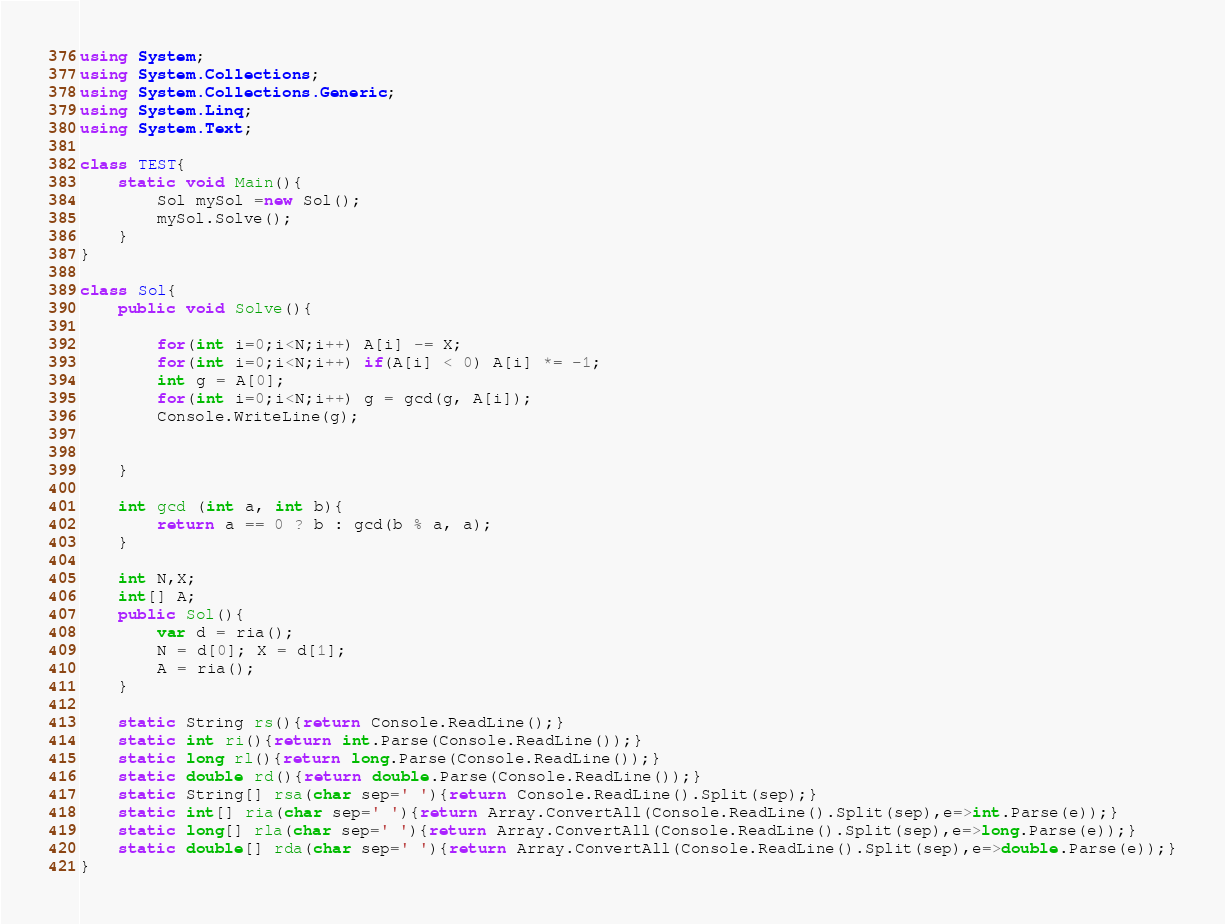Convert code to text. <code><loc_0><loc_0><loc_500><loc_500><_C#_>using System;
using System.Collections;
using System.Collections.Generic;
using System.Linq;
using System.Text;

class TEST{
	static void Main(){
		Sol mySol =new Sol();
		mySol.Solve();
	}
}

class Sol{
	public void Solve(){
		
		for(int i=0;i<N;i++) A[i] -= X;
		for(int i=0;i<N;i++) if(A[i] < 0) A[i] *= -1;
		int g = A[0];
		for(int i=0;i<N;i++) g = gcd(g, A[i]);
		Console.WriteLine(g);
		
		
	}
	
	int gcd (int a, int b){
		return a == 0 ? b : gcd(b % a, a);
	}
	
	int N,X;
	int[] A;
	public Sol(){
		var d = ria();
		N = d[0]; X = d[1];
		A = ria();
	}

	static String rs(){return Console.ReadLine();}
	static int ri(){return int.Parse(Console.ReadLine());}
	static long rl(){return long.Parse(Console.ReadLine());}
	static double rd(){return double.Parse(Console.ReadLine());}
	static String[] rsa(char sep=' '){return Console.ReadLine().Split(sep);}
	static int[] ria(char sep=' '){return Array.ConvertAll(Console.ReadLine().Split(sep),e=>int.Parse(e));}
	static long[] rla(char sep=' '){return Array.ConvertAll(Console.ReadLine().Split(sep),e=>long.Parse(e));}
	static double[] rda(char sep=' '){return Array.ConvertAll(Console.ReadLine().Split(sep),e=>double.Parse(e));}
}
</code> 